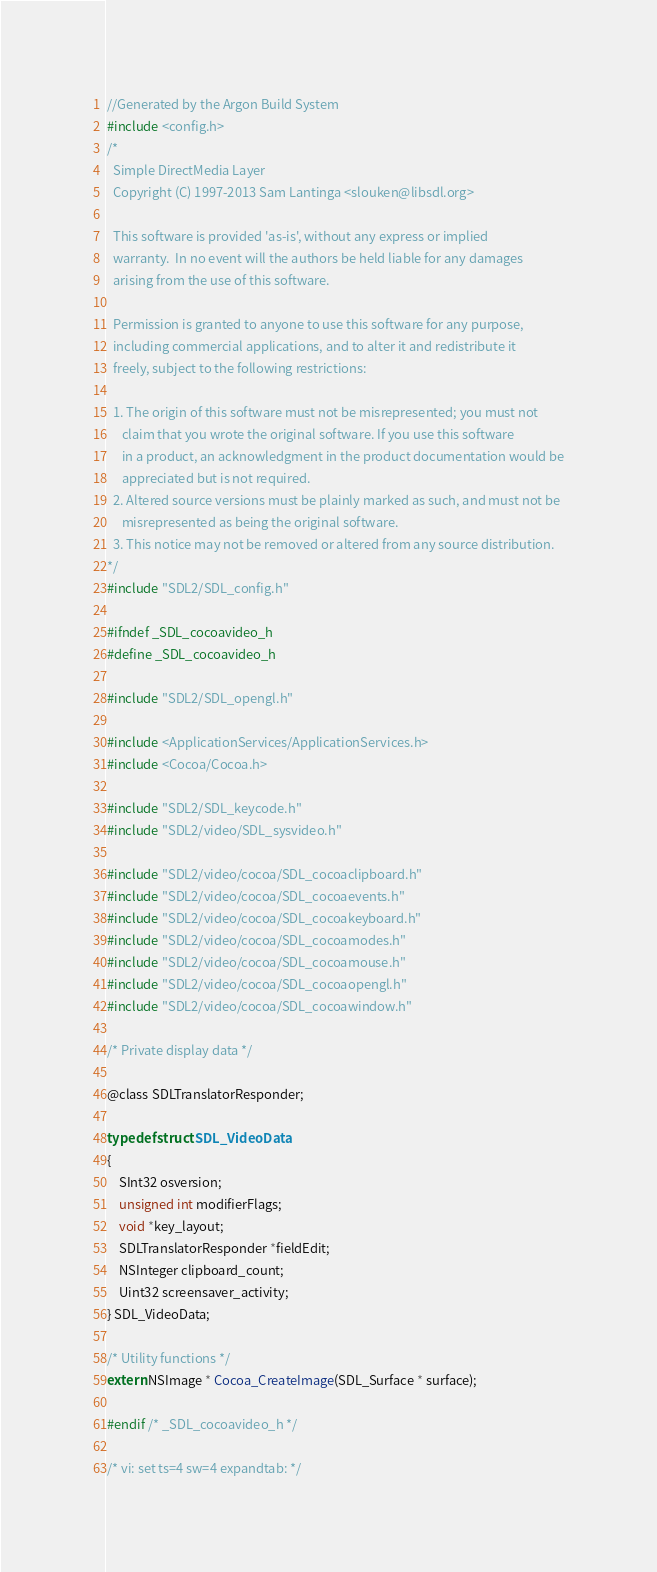<code> <loc_0><loc_0><loc_500><loc_500><_C_>//Generated by the Argon Build System
#include <config.h>
/*
  Simple DirectMedia Layer
  Copyright (C) 1997-2013 Sam Lantinga <slouken@libsdl.org>

  This software is provided 'as-is', without any express or implied
  warranty.  In no event will the authors be held liable for any damages
  arising from the use of this software.

  Permission is granted to anyone to use this software for any purpose,
  including commercial applications, and to alter it and redistribute it
  freely, subject to the following restrictions:

  1. The origin of this software must not be misrepresented; you must not
     claim that you wrote the original software. If you use this software
     in a product, an acknowledgment in the product documentation would be
     appreciated but is not required.
  2. Altered source versions must be plainly marked as such, and must not be
     misrepresented as being the original software.
  3. This notice may not be removed or altered from any source distribution.
*/
#include "SDL2/SDL_config.h"

#ifndef _SDL_cocoavideo_h
#define _SDL_cocoavideo_h

#include "SDL2/SDL_opengl.h"

#include <ApplicationServices/ApplicationServices.h>
#include <Cocoa/Cocoa.h>

#include "SDL2/SDL_keycode.h"
#include "SDL2/video/SDL_sysvideo.h"

#include "SDL2/video/cocoa/SDL_cocoaclipboard.h"
#include "SDL2/video/cocoa/SDL_cocoaevents.h"
#include "SDL2/video/cocoa/SDL_cocoakeyboard.h"
#include "SDL2/video/cocoa/SDL_cocoamodes.h"
#include "SDL2/video/cocoa/SDL_cocoamouse.h"
#include "SDL2/video/cocoa/SDL_cocoaopengl.h"
#include "SDL2/video/cocoa/SDL_cocoawindow.h"

/* Private display data */

@class SDLTranslatorResponder;

typedef struct SDL_VideoData
{
    SInt32 osversion;
    unsigned int modifierFlags;
    void *key_layout;
    SDLTranslatorResponder *fieldEdit;
    NSInteger clipboard_count;
    Uint32 screensaver_activity;
} SDL_VideoData;

/* Utility functions */
extern NSImage * Cocoa_CreateImage(SDL_Surface * surface);

#endif /* _SDL_cocoavideo_h */

/* vi: set ts=4 sw=4 expandtab: */
</code> 